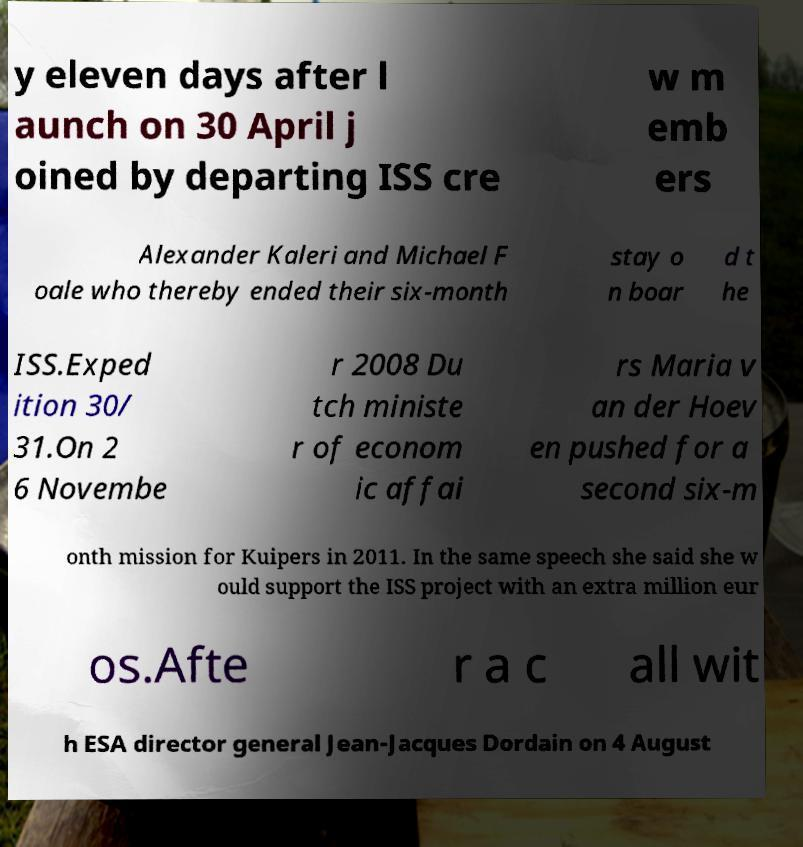Please identify and transcribe the text found in this image. y eleven days after l aunch on 30 April j oined by departing ISS cre w m emb ers Alexander Kaleri and Michael F oale who thereby ended their six-month stay o n boar d t he ISS.Exped ition 30/ 31.On 2 6 Novembe r 2008 Du tch ministe r of econom ic affai rs Maria v an der Hoev en pushed for a second six-m onth mission for Kuipers in 2011. In the same speech she said she w ould support the ISS project with an extra million eur os.Afte r a c all wit h ESA director general Jean-Jacques Dordain on 4 August 